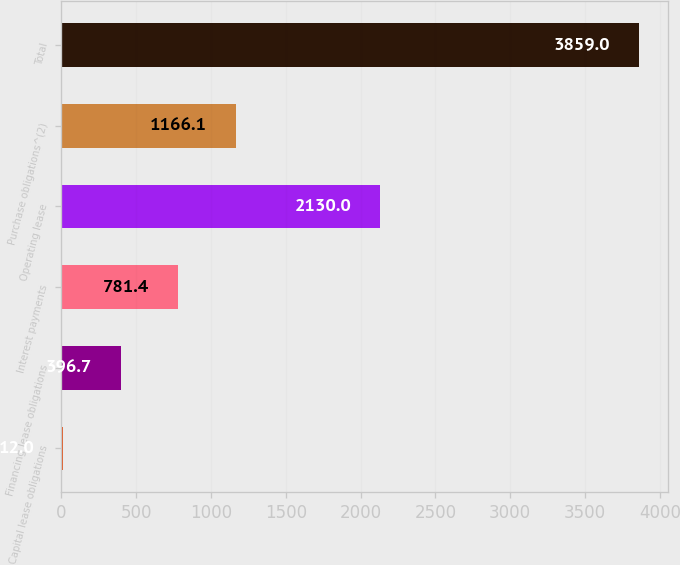Convert chart to OTSL. <chart><loc_0><loc_0><loc_500><loc_500><bar_chart><fcel>Capital lease obligations<fcel>Financing lease obligations<fcel>Interest payments<fcel>Operating lease<fcel>Purchase obligations^(2)<fcel>Total<nl><fcel>12<fcel>396.7<fcel>781.4<fcel>2130<fcel>1166.1<fcel>3859<nl></chart> 